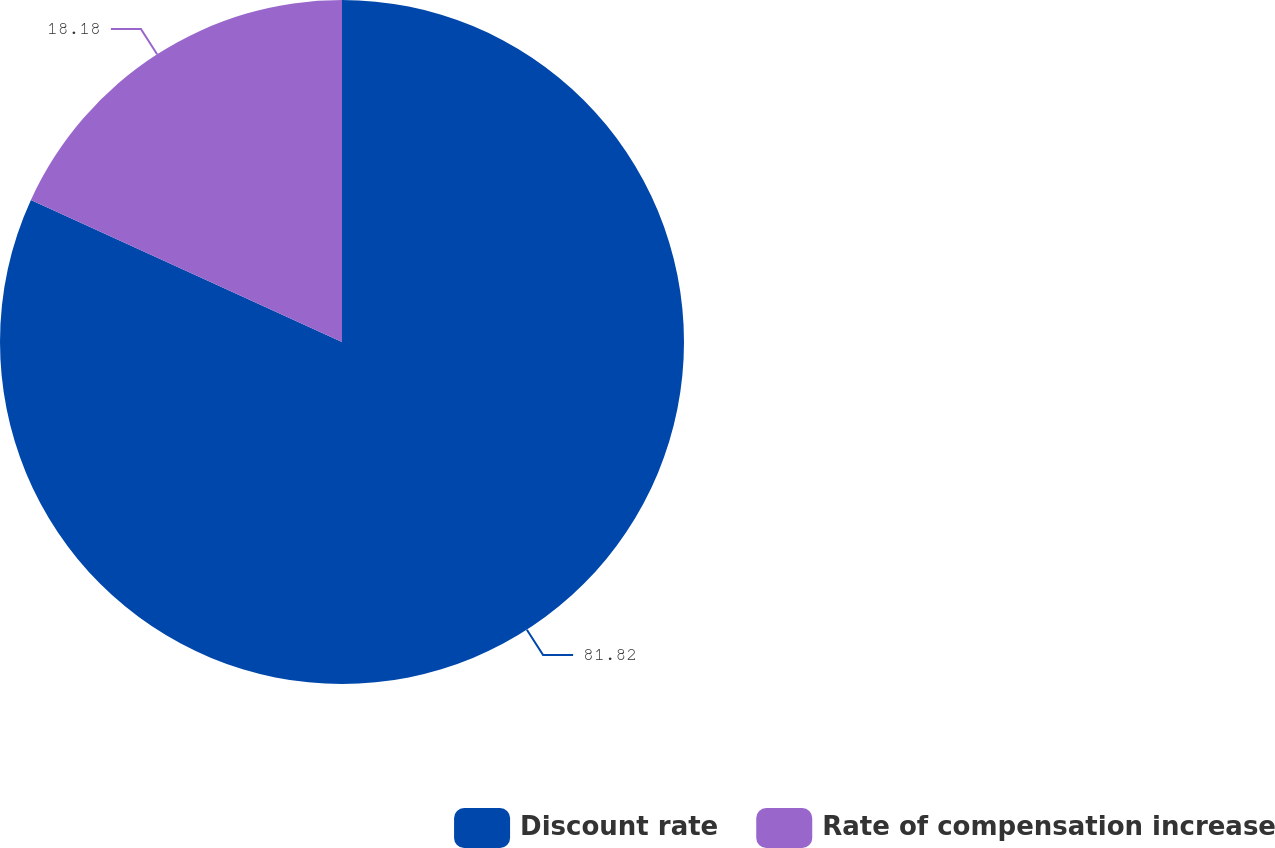Convert chart. <chart><loc_0><loc_0><loc_500><loc_500><pie_chart><fcel>Discount rate<fcel>Rate of compensation increase<nl><fcel>81.82%<fcel>18.18%<nl></chart> 